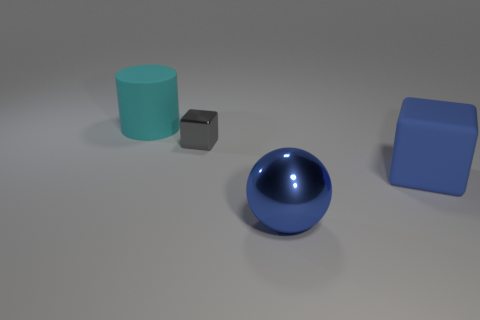What lighting conditions are observed in the scene and how do they affect the appearance of the objects? The scene is softly lit from what seems to be an unidentified overhead light source, casting gentle shadows beneath each object. This lighting provides a fairly neutral setting where the inherent colors and textures of the objects are clearly visible. It particularly enhances the reflective qualities of the metallic sphere, allowing it to stand out against the matte surfaces of the other objects. 